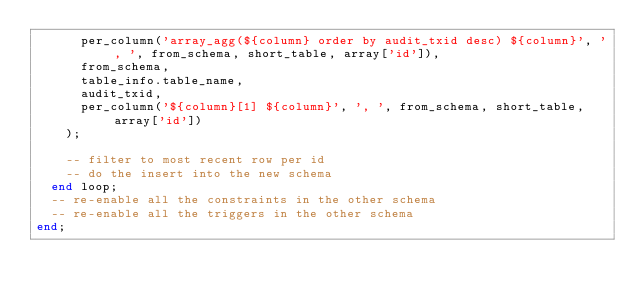<code> <loc_0><loc_0><loc_500><loc_500><_SQL_>      per_column('array_agg(${column} order by audit_txid desc) ${column}', ', ', from_schema, short_table, array['id']),
      from_schema,
      table_info.table_name,
      audit_txid,
      per_column('${column}[1] ${column}', ', ', from_schema, short_table, array['id'])
    );

    -- filter to most recent row per id
    -- do the insert into the new schema
  end loop;
  -- re-enable all the constraints in the other schema
  -- re-enable all the triggers in the other schema
end;</code> 